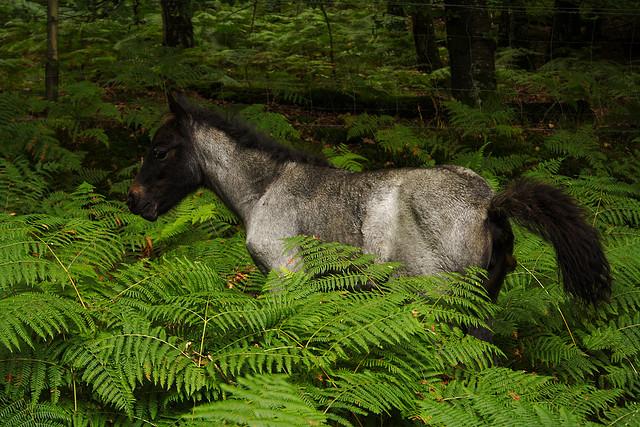What color is the horse?
Write a very short answer. Gray. What color is the horse's coat?
Keep it brief. Gray. Is this a wild horse?
Answer briefly. Yes. What is this animal?
Be succinct. Horse. What type of animal is this?
Quick response, please. Horse. Would you be scared if this was your viewpoint in real life?
Short answer required. No. What fairy tale does this picture suggest?
Give a very brief answer. Shrek. What is the name of the animal?
Answer briefly. Horse. What kind of animal is this?
Write a very short answer. Donkey. Do you see a park bench?
Keep it brief. No. What type of plant is shown?
Keep it brief. Fern. 